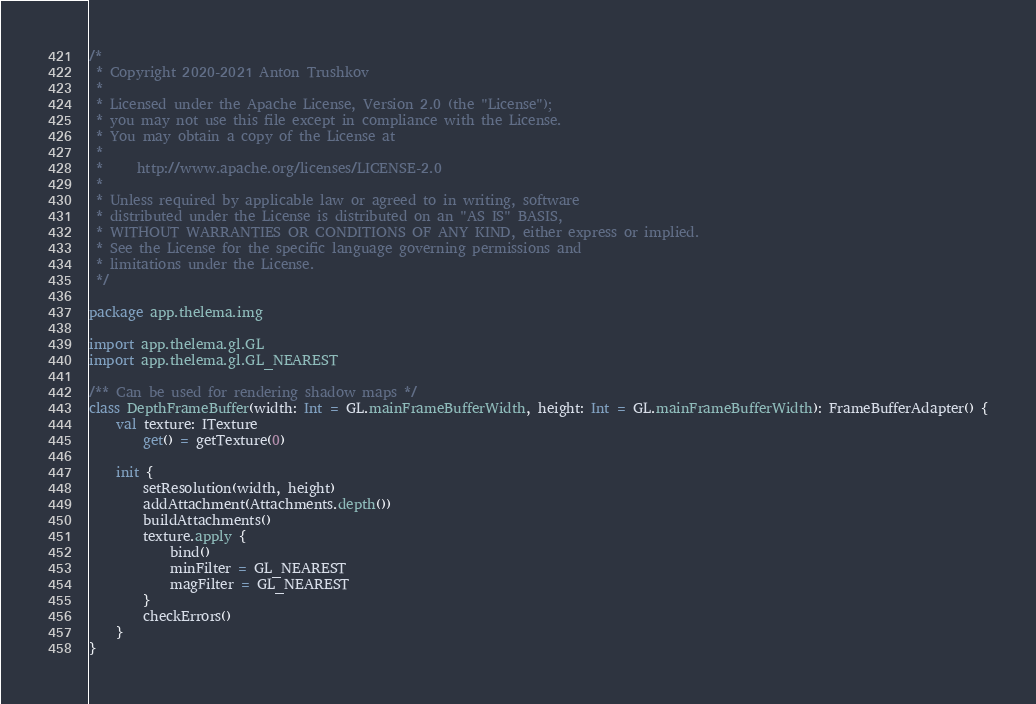<code> <loc_0><loc_0><loc_500><loc_500><_Kotlin_>/*
 * Copyright 2020-2021 Anton Trushkov
 *
 * Licensed under the Apache License, Version 2.0 (the "License");
 * you may not use this file except in compliance with the License.
 * You may obtain a copy of the License at
 *
 *     http://www.apache.org/licenses/LICENSE-2.0
 *
 * Unless required by applicable law or agreed to in writing, software
 * distributed under the License is distributed on an "AS IS" BASIS,
 * WITHOUT WARRANTIES OR CONDITIONS OF ANY KIND, either express or implied.
 * See the License for the specific language governing permissions and
 * limitations under the License.
 */

package app.thelema.img

import app.thelema.gl.GL
import app.thelema.gl.GL_NEAREST

/** Can be used for rendering shadow maps */
class DepthFrameBuffer(width: Int = GL.mainFrameBufferWidth, height: Int = GL.mainFrameBufferWidth): FrameBufferAdapter() {
    val texture: ITexture
        get() = getTexture(0)

    init {
        setResolution(width, height)
        addAttachment(Attachments.depth())
        buildAttachments()
        texture.apply {
            bind()
            minFilter = GL_NEAREST
            magFilter = GL_NEAREST
        }
        checkErrors()
    }
}</code> 